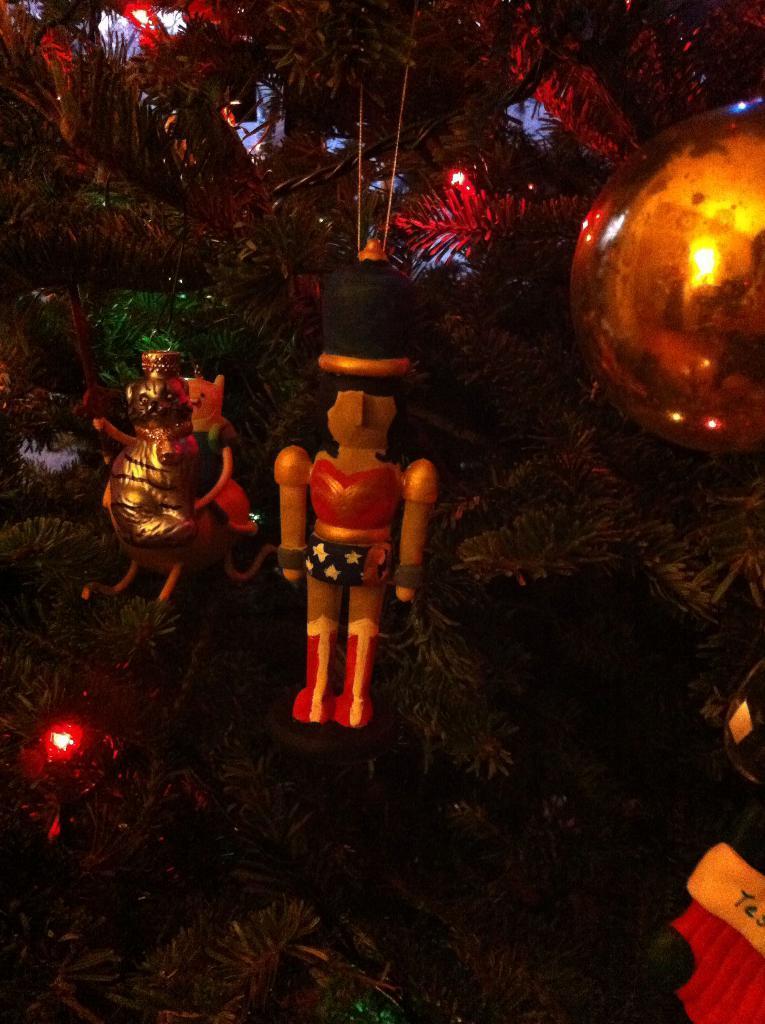Describe this image in one or two sentences. In this picture we can see a Christmas tree and decorative objects. 